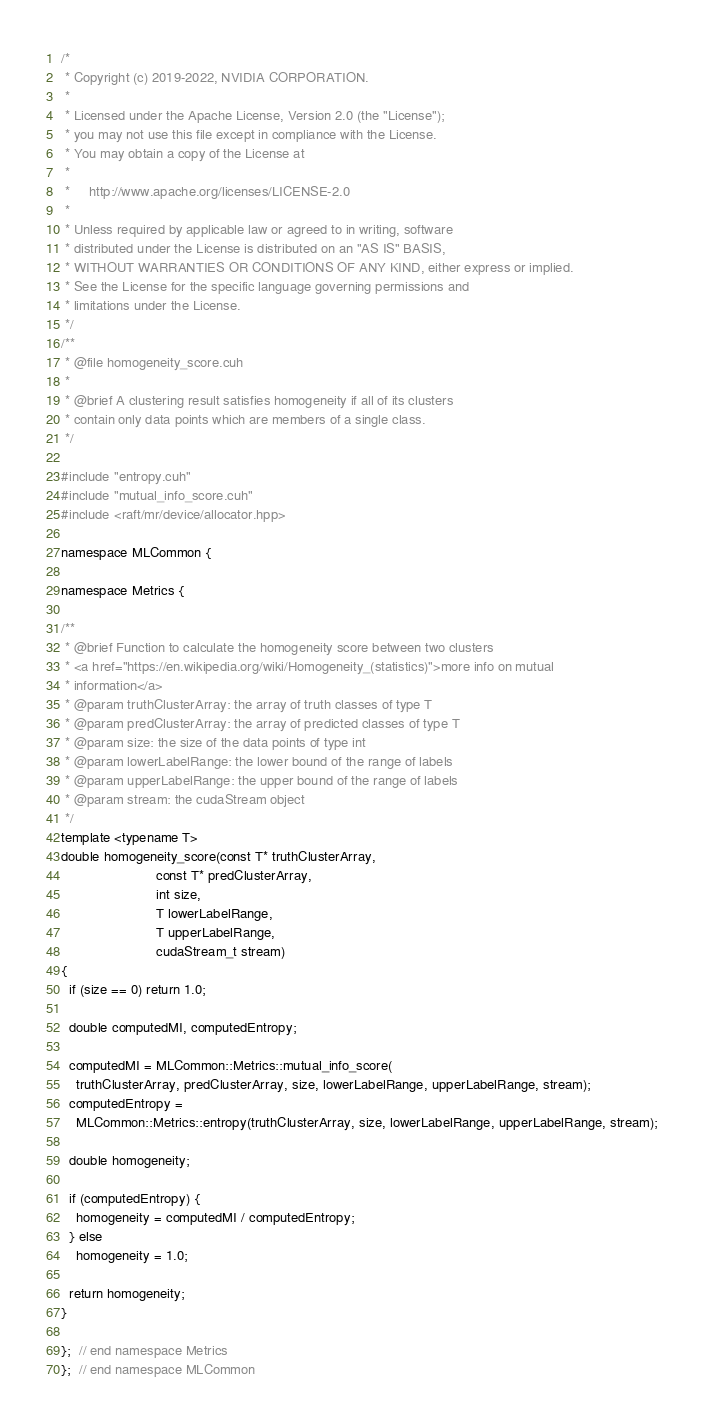Convert code to text. <code><loc_0><loc_0><loc_500><loc_500><_Cuda_>/*
 * Copyright (c) 2019-2022, NVIDIA CORPORATION.
 *
 * Licensed under the Apache License, Version 2.0 (the "License");
 * you may not use this file except in compliance with the License.
 * You may obtain a copy of the License at
 *
 *     http://www.apache.org/licenses/LICENSE-2.0
 *
 * Unless required by applicable law or agreed to in writing, software
 * distributed under the License is distributed on an "AS IS" BASIS,
 * WITHOUT WARRANTIES OR CONDITIONS OF ANY KIND, either express or implied.
 * See the License for the specific language governing permissions and
 * limitations under the License.
 */
/**
 * @file homogeneity_score.cuh
 *
 * @brief A clustering result satisfies homogeneity if all of its clusters
 * contain only data points which are members of a single class.
 */

#include "entropy.cuh"
#include "mutual_info_score.cuh"
#include <raft/mr/device/allocator.hpp>

namespace MLCommon {

namespace Metrics {

/**
 * @brief Function to calculate the homogeneity score between two clusters
 * <a href="https://en.wikipedia.org/wiki/Homogeneity_(statistics)">more info on mutual
 * information</a>
 * @param truthClusterArray: the array of truth classes of type T
 * @param predClusterArray: the array of predicted classes of type T
 * @param size: the size of the data points of type int
 * @param lowerLabelRange: the lower bound of the range of labels
 * @param upperLabelRange: the upper bound of the range of labels
 * @param stream: the cudaStream object
 */
template <typename T>
double homogeneity_score(const T* truthClusterArray,
                         const T* predClusterArray,
                         int size,
                         T lowerLabelRange,
                         T upperLabelRange,
                         cudaStream_t stream)
{
  if (size == 0) return 1.0;

  double computedMI, computedEntropy;

  computedMI = MLCommon::Metrics::mutual_info_score(
    truthClusterArray, predClusterArray, size, lowerLabelRange, upperLabelRange, stream);
  computedEntropy =
    MLCommon::Metrics::entropy(truthClusterArray, size, lowerLabelRange, upperLabelRange, stream);

  double homogeneity;

  if (computedEntropy) {
    homogeneity = computedMI / computedEntropy;
  } else
    homogeneity = 1.0;

  return homogeneity;
}

};  // end namespace Metrics
};  // end namespace MLCommon
</code> 